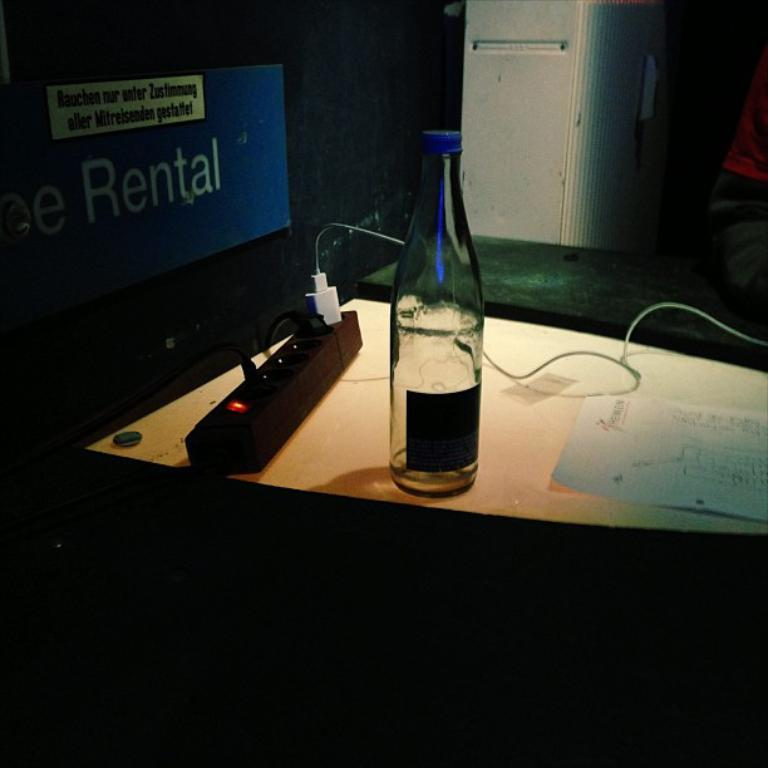<image>
Write a terse but informative summary of the picture. A sign that says rental is behind a power strip. 